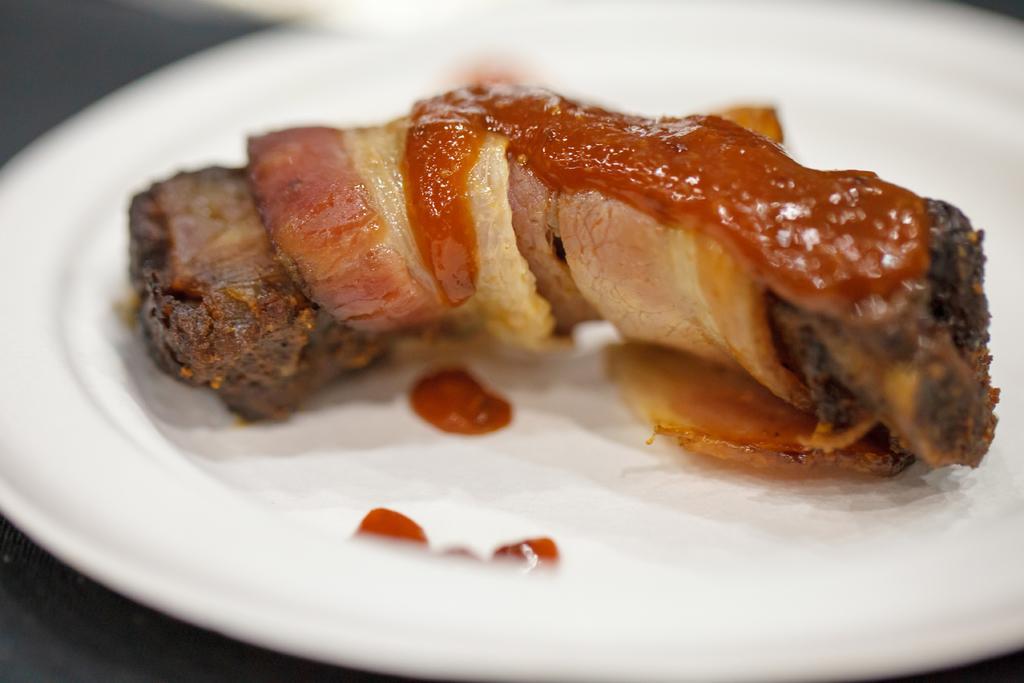In one or two sentences, can you explain what this image depicts? In this image we can see some food item is kept on the white color plate. This part of the image is blurred. 